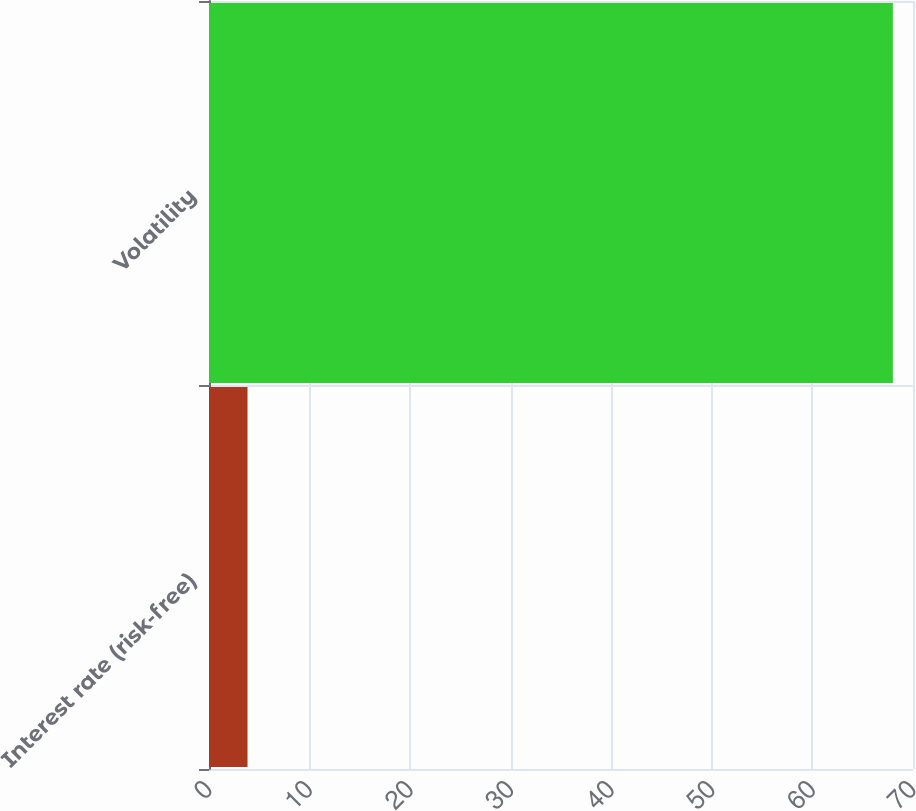Convert chart. <chart><loc_0><loc_0><loc_500><loc_500><bar_chart><fcel>Interest rate (risk-free)<fcel>Volatility<nl><fcel>3.83<fcel>68<nl></chart> 